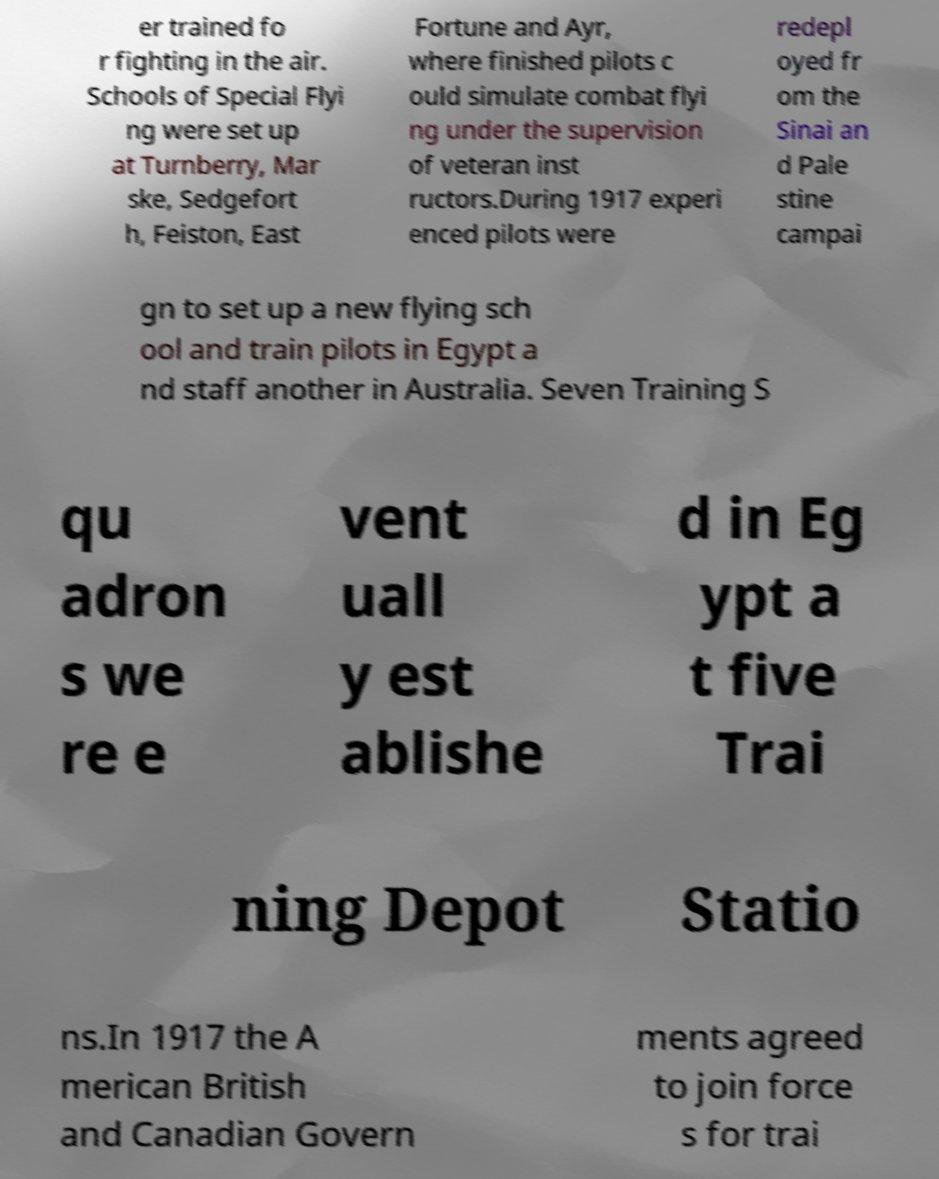For documentation purposes, I need the text within this image transcribed. Could you provide that? er trained fo r fighting in the air. Schools of Special Flyi ng were set up at Turnberry, Mar ske, Sedgefort h, Feiston, East Fortune and Ayr, where finished pilots c ould simulate combat flyi ng under the supervision of veteran inst ructors.During 1917 experi enced pilots were redepl oyed fr om the Sinai an d Pale stine campai gn to set up a new flying sch ool and train pilots in Egypt a nd staff another in Australia. Seven Training S qu adron s we re e vent uall y est ablishe d in Eg ypt a t five Trai ning Depot Statio ns.In 1917 the A merican British and Canadian Govern ments agreed to join force s for trai 